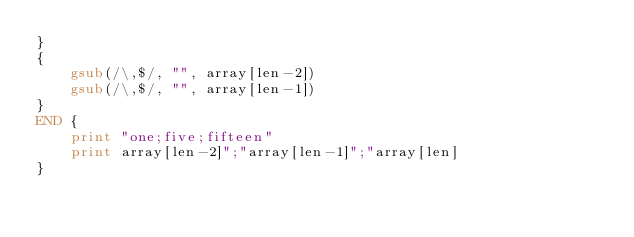Convert code to text. <code><loc_0><loc_0><loc_500><loc_500><_Awk_>}
{
    gsub(/\,$/, "", array[len-2])
    gsub(/\,$/, "", array[len-1])
}
END {
    print "one;five;fifteen"
    print array[len-2]";"array[len-1]";"array[len]
}</code> 